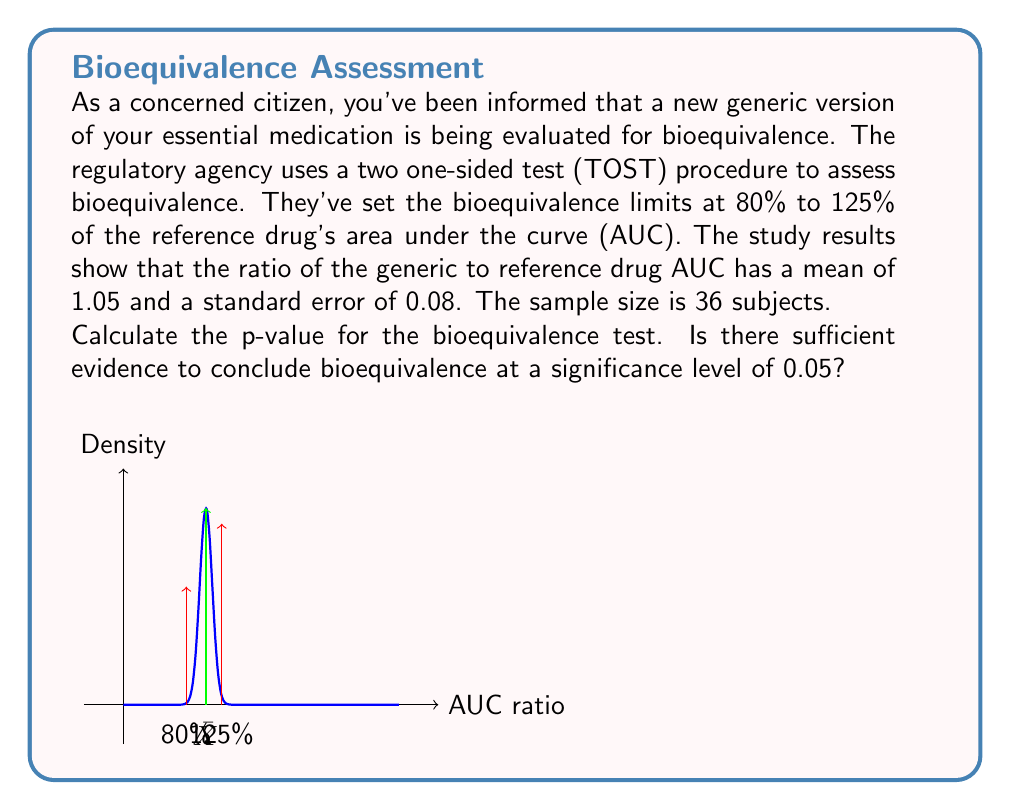Give your solution to this math problem. To assess bioequivalence using TOST, we need to perform two one-sided t-tests:

1. $H_{01}: \mu \leq 0.8$ vs $H_{A1}: \mu > 0.8$
2. $H_{02}: \mu \geq 1.25$ vs $H_{A2}: \mu < 1.25$

Where $\mu$ is the population mean ratio of AUCs.

Step 1: Calculate t-statistics for both tests
$t_1 = \frac{\bar{X} - 0.8}{SE/\sqrt{n}}$ and $t_2 = \frac{1.25 - \bar{X}}{SE/\sqrt{n}}$

$t_1 = \frac{1.05 - 0.8}{0.08/\sqrt{36}} = \frac{0.25}{0.08/6} = 18.75$

$t_2 = \frac{1.25 - 1.05}{0.08/\sqrt{36}} = \frac{0.20}{0.08/6} = 15$

Step 2: Find p-values for both t-statistics
$p_1 = 1 - T_{35}(18.75)$
$p_2 = T_{35}(15)$

Where $T_{35}$ is the cumulative t-distribution with 35 degrees of freedom.

Step 3: The overall p-value for TOST is the maximum of $p_1$ and $p_2$
$p_{TOST} = \max(p_1, p_2)$

Using statistical software or tables, we find:
$p_1 \approx 3.33 \times 10^{-20}$
$p_2 \approx 1.92 \times 10^{-17}$

Therefore, $p_{TOST} = 1.92 \times 10^{-17}$

Step 4: Compare $p_{TOST}$ to the significance level $\alpha = 0.05$

Since $p_{TOST} < \alpha$, we reject both null hypotheses and conclude bioequivalence.
Answer: $p_{TOST} = 1.92 \times 10^{-17}$; Bioequivalence concluded 